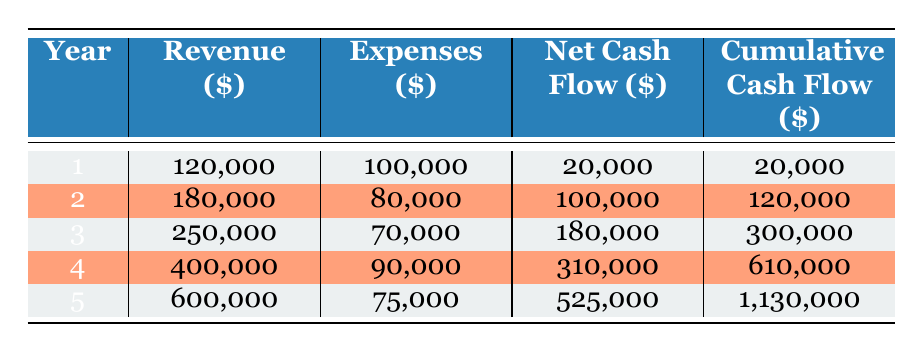What was the revenue in year 3? The table indicates that the revenue for year 3 is listed directly under the Revenue column in that row, showing a value of 250,000.
Answer: 250000 What was the total revenue generated over the entire 5-year project? To find the total revenue, we add the revenues for all five years: 120,000 + 180,000 + 250,000 + 400,000 + 600,000 = 1,550,000.
Answer: 1550000 Did the annual expenses decrease from year 1 to year 5? In year 1, expenses were 100,000, while in year 5, they were 75,000, indicating a decrease.
Answer: Yes What is the net cash flow for year 2 and how does it compare to year 4? The net cash flow for year 2 is 100,000 and for year 4 is 310,000. To compare, year 4 has a significantly higher net cash flow than year 2, specifically 210,000 more.
Answer: Year 4 is 210000 more than year 2 What was the cumulative cash flow by the end of year 4? The cumulative cash flow at the end of year 4 is given in the table and is displayed as 610,000 in the respective row.
Answer: 610000 What is the average net cash flow over the 5 years? To calculate the average net cash flow, we sum the net cash flows for all 5 years (20,000 + 100,000 + 180,000 + 310,000 + 525,000 = 1,135,000) and divide by 5: 1,135,000 / 5 = 227,000.
Answer: 227000 Was there a year with a net cash flow of less than 50,000? Upon reviewing the net cash flow values, year 1 has a net cash flow of 20,000, which is less than 50,000.
Answer: Yes In which year did the cumulative cash flow first exceed 500,000? Looking at the cumulative cash flow values, we find that it first exceeds 500,000 in year 4, where it reaches 610,000.
Answer: Year 4 What is the difference between the total revenue and total expenses over the 5-year period? First, we will calculate total revenue (1,550,000) and total expenses (100,000 + 80,000 + 70,000 + 90,000 + 75,000 = 415,000), then subtract: 1,550,000 - 415,000 = 1,135,000.
Answer: 1135000 